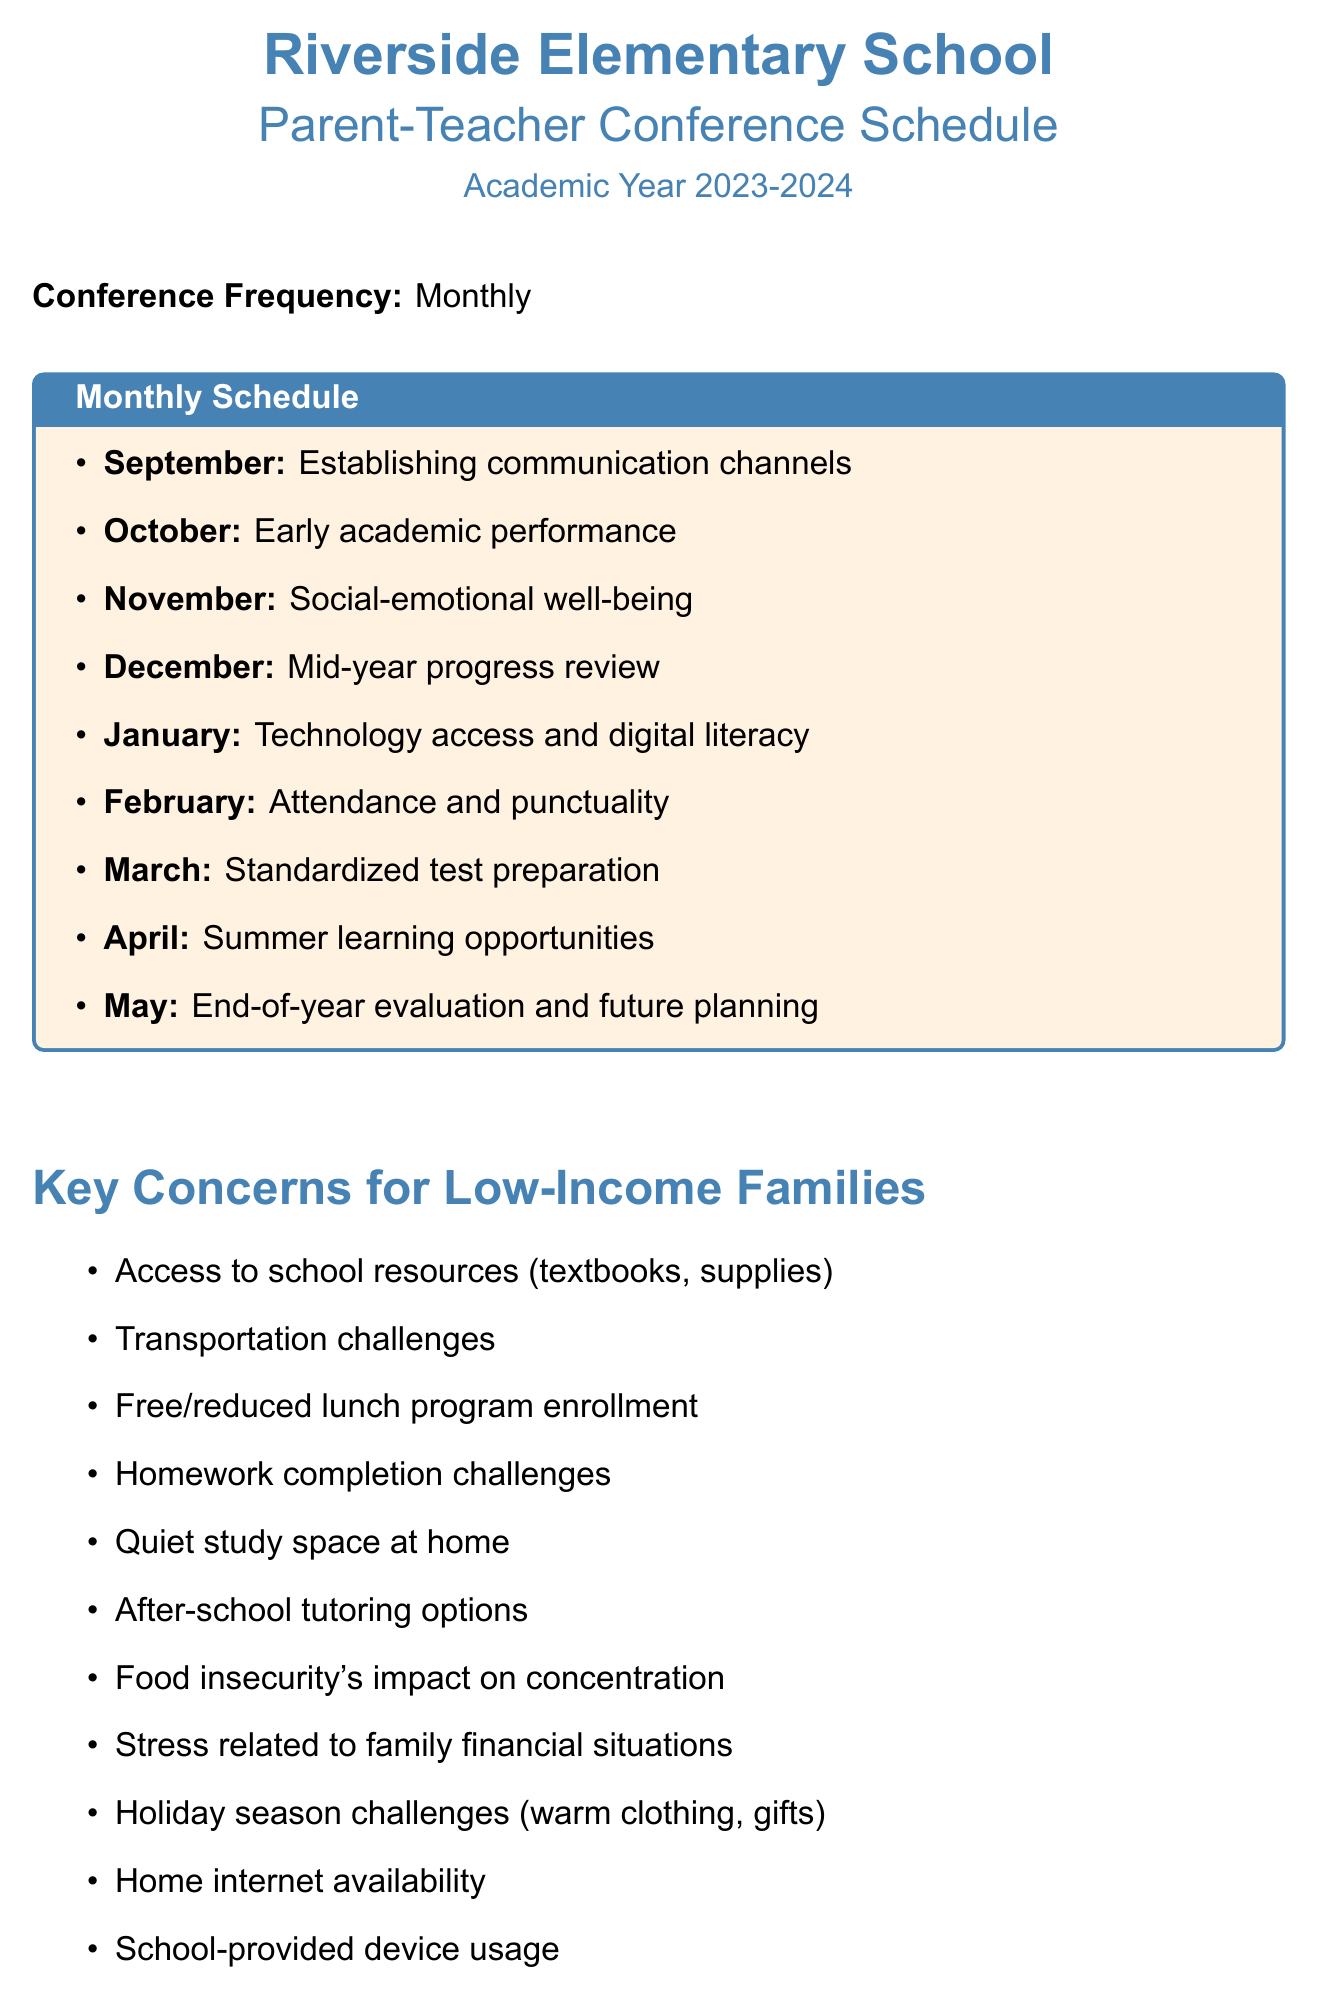What is the name of the school? The school name is mentioned at the beginning of the document as Riverside Elementary School.
Answer: Riverside Elementary School How often are the parent-teacher conferences held? The document specifies that the frequency of the conferences is monthly.
Answer: Monthly What month focuses on social-emotional well-being? The document lists the focus topics for each month, and November is designated for social-emotional well-being.
Answer: November What specific concern is addressed in January? The document states that January focuses on technology access and digital literacy, indicating the specific concerns related to that topic.
Answer: Technology access and digital literacy Which resource helps with financial counseling? The community resources section provides a list, and the Family Resource Center is the one that offers financial counseling services.
Answer: Family Resource Center What program provides free morning meals? The document mentions the Breakfast Buddies program, which offers free morning meals and tutoring.
Answer: Breakfast Buddies How many months focus on academic performance? By analyzing the monthly topics, there are two months, September and October, that focus on academic performance-related issues.
Answer: Two months What does the Weekend Wellness program provide? The document describes the Weekend Wellness program as providing take-home meals and hygiene supplies for weekends.
Answer: Take-home meals and hygiene supplies What is a concern related to holiday challenges? The document specifies that one of the concerns during the holiday season is discussing warm clothing and gifts.
Answer: Warm clothing and gifts 